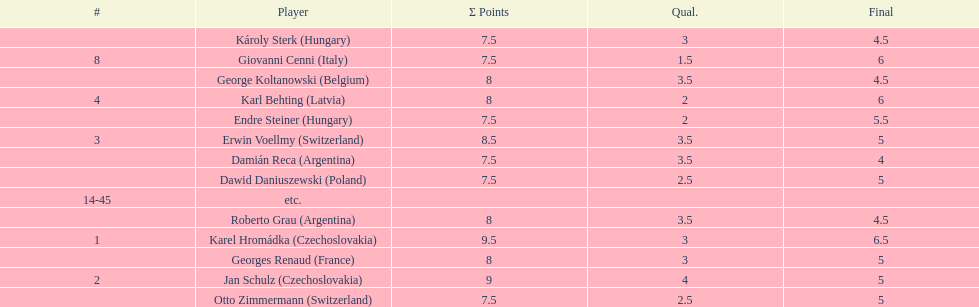Jan schulz is ranked immediately below which player? Karel Hromádka. 